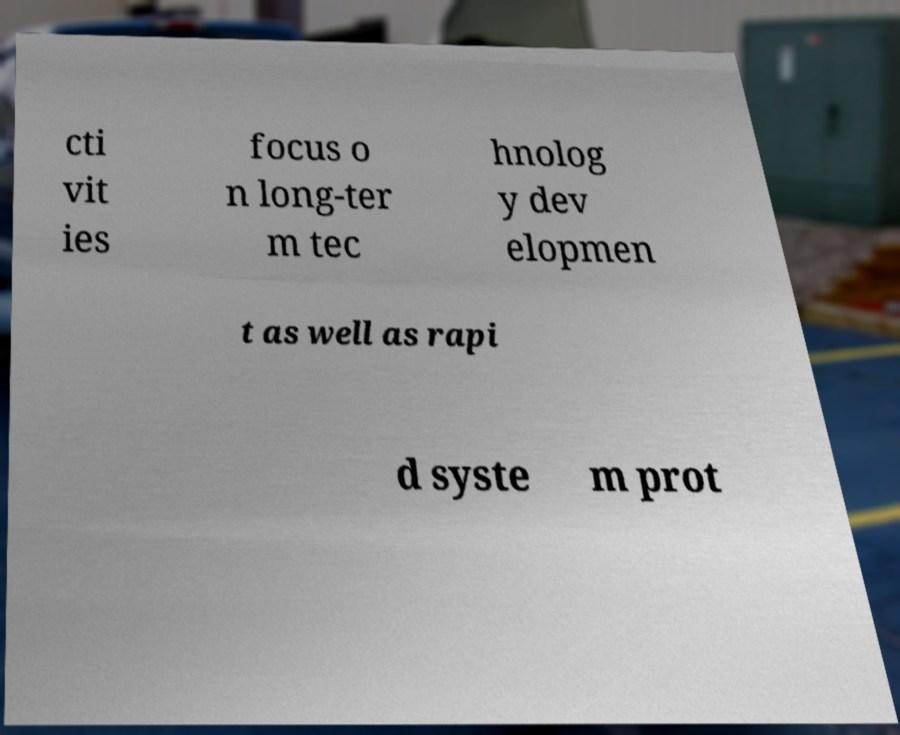Please identify and transcribe the text found in this image. cti vit ies focus o n long-ter m tec hnolog y dev elopmen t as well as rapi d syste m prot 